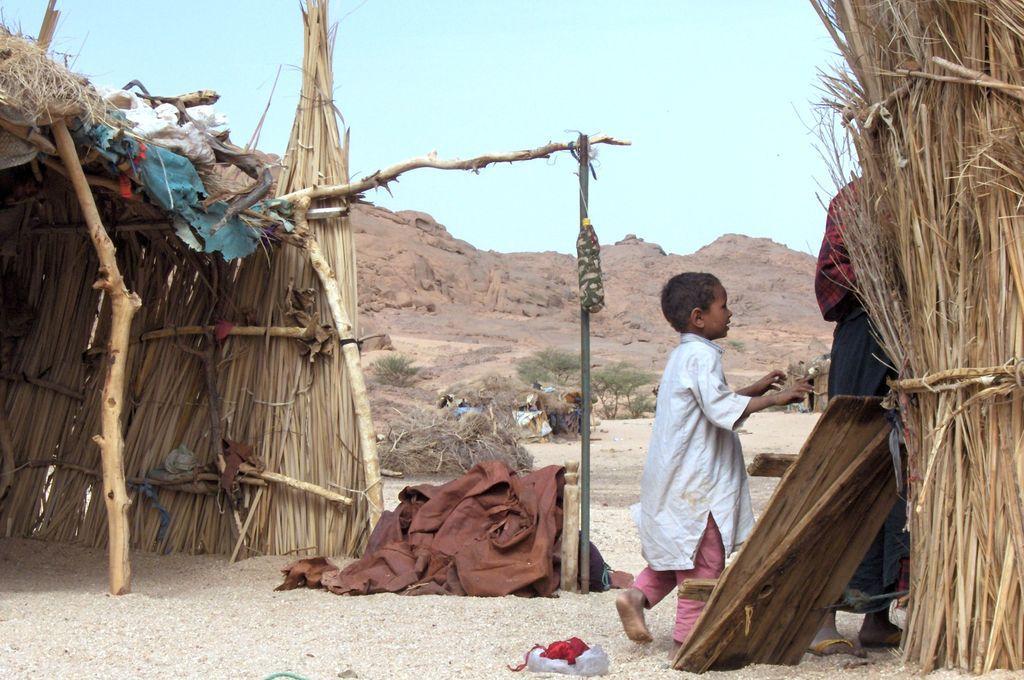Could you give a brief overview of what you see in this image? In the foreground of this picture, there are two huts, a wooden plank, a boy and a woman standing on the sand, a bottle hanging to a pole and a brown carpet on the ground. In the background, we can see trees, huts, cliffs, and the sky. 